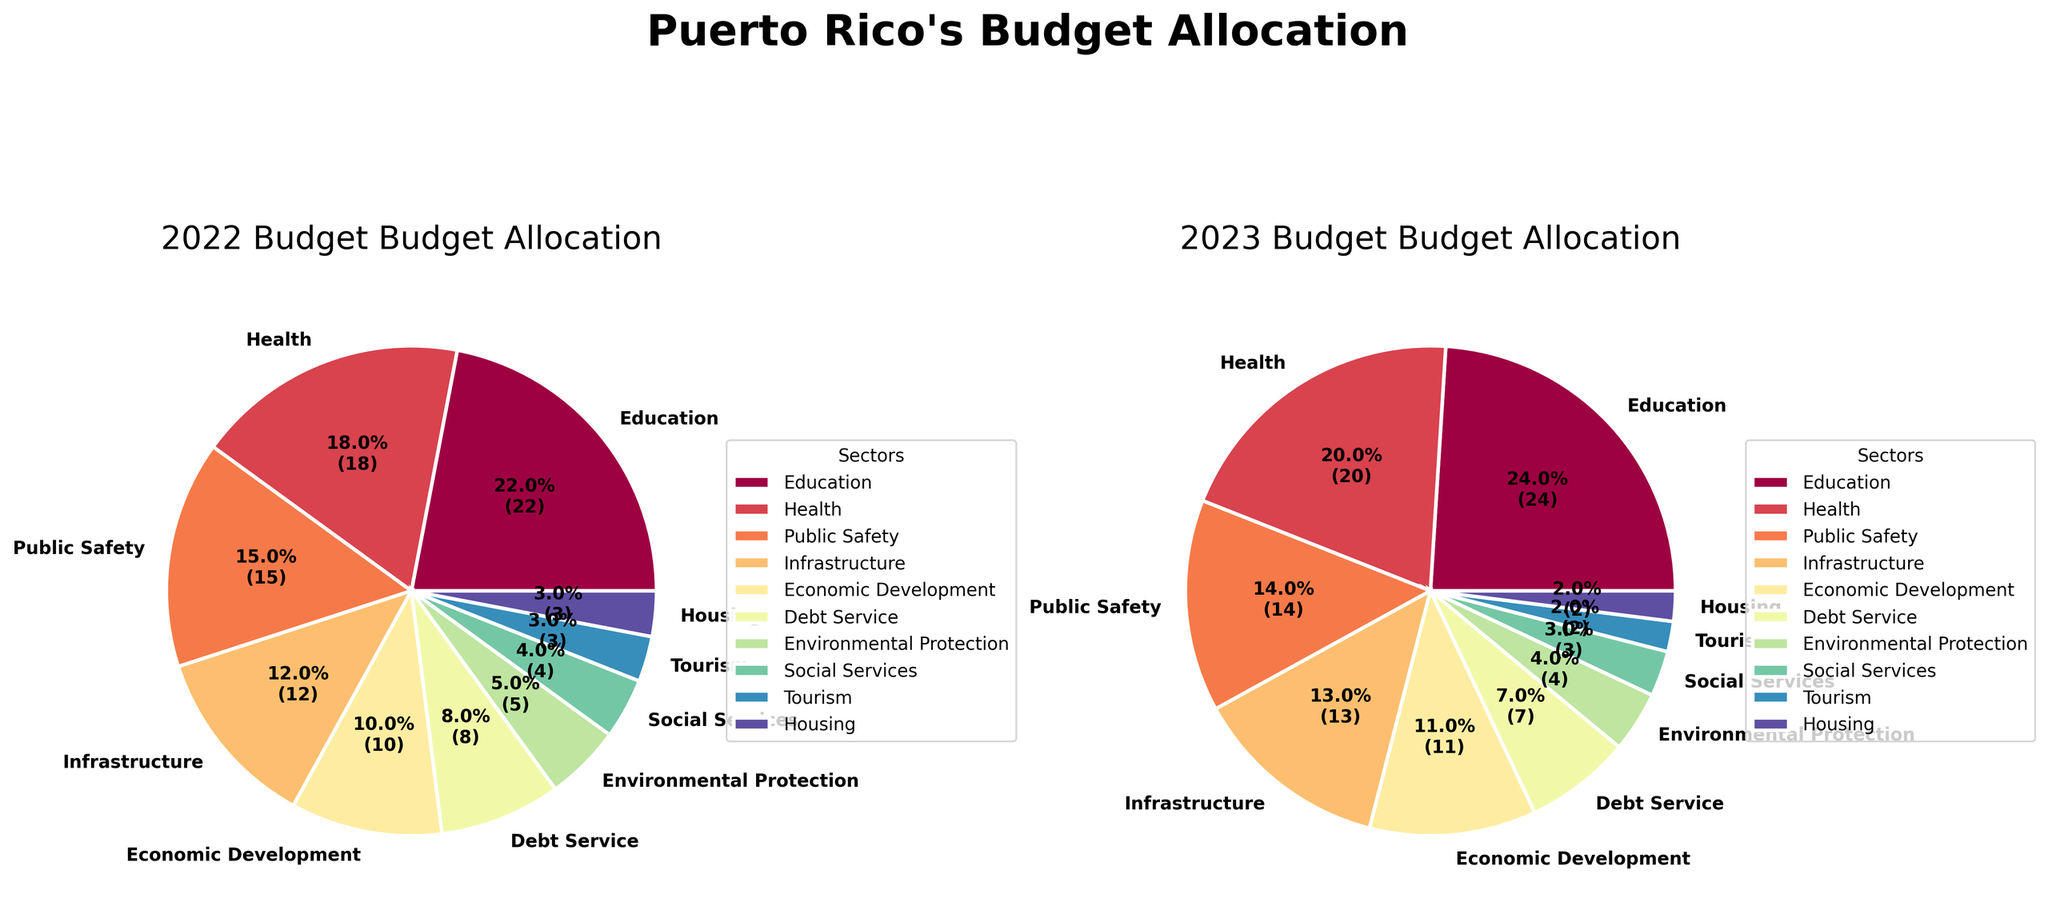What is the title of the figure? The title is typically found at the top center of the figure. Here, it reads "Puerto Rico's Budget Allocation".
Answer: Puerto Rico's Budget Allocation What sector got the highest allocation in the 2022 budget? Look at the largest pie slice in the 2022 Budget pie chart. It's labeled "Education".
Answer: Education How much did the budget allocation for Health change from 2022 to 2023? Subtract the 2022 allocation for Health (18%) from the 2023 allocation for Health (20%). The change is 20% - 18% = 2%.
Answer: 2% Which sector saw a decrease in its budget allocation from 2022 to 2023? Compare each sector's budget allocation in both years. Public Safety, Debt Service, Environmental Protection, Social Services, Tourism, and Housing saw a decrease.
Answer: Public Safety, Debt Service, Environmental Protection, Social Services, Tourism, Housing What is the combined budget allocation for Education and Health in 2023? Add the allocations for Education (24%) and Health (20%) in 2023. The combined allocation is 24% + 20% = 44%.
Answer: 44% Which two sectors have the smallest budget allocations in 2023, and what are their percentages? Look at the labels with the smallest slices in the 2023 Budget pie chart. They are Housing and Tourism, both with 2% each.
Answer: Housing: 2%, Tourism: 2% Which sector received the same percentage of the budget in 2022 and 2023? Compare the percentage allocations for each sector in both years. No sector received the same allocation percentage in both years.
Answer: None How do the total allocations for Infrastructure and Economic Development compare between 2022 and 2023? For 2022, add Infrastructure (12%) and Economic Development (10%) for a total of 22%. For 2023, add Infrastructure (13%) and Economic Development (11%) for a total of 24%. 24% > 22%.
Answer: 2023 > 2022 What is the title of the left pie chart, and what information does it convey? The title above the left pie chart is "2022 Budget Allocation". This chart shows the budget distribution across different sectors for the year 2022.
Answer: 2022 Budget Allocation By how much did the allocation for Debt Service change from 2022 to 2023? Subtract the 2023 allocation for Debt Service (7%) from the 2022 allocation for Debt Service (8%). The change is 8% - 7% = 1%.
Answer: 1% 